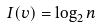<formula> <loc_0><loc_0><loc_500><loc_500>I ( v ) = \log _ { 2 } n</formula> 